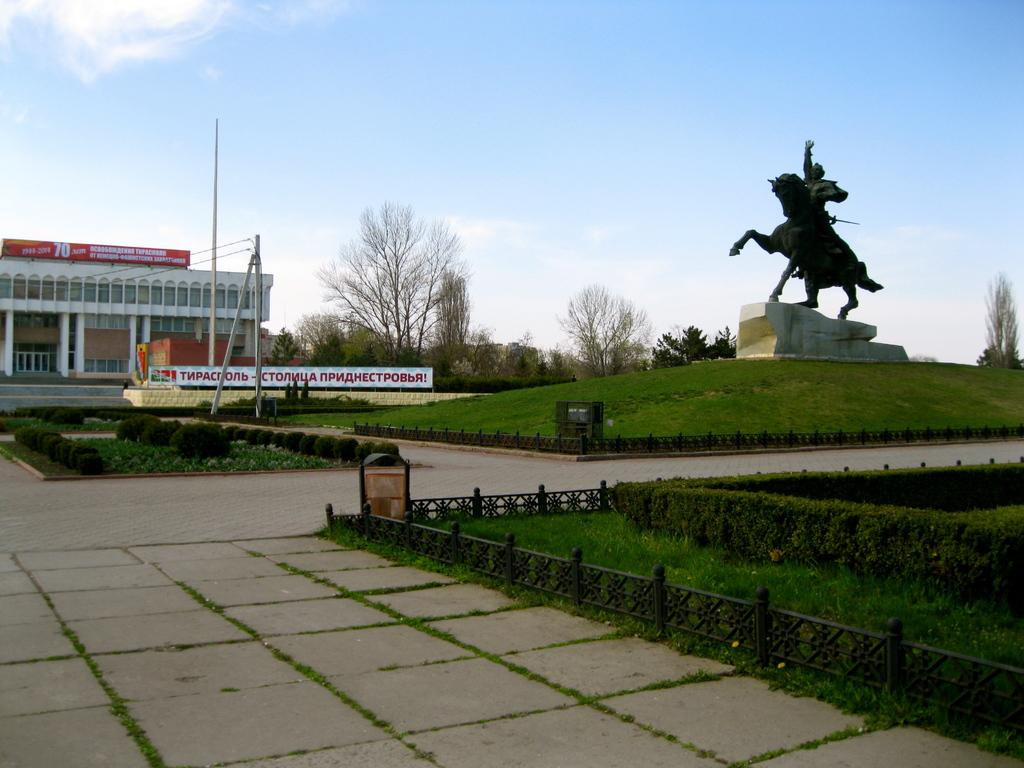What structure is located on the left side of the image? There is a house on the left side of the image. What type of landscape surrounds the house? The house appears to be surrounded by a garden. What can be seen on the right side of the image? There is a statue of a man riding a horse on the right side of the image. What type of vegetation is in the middle of the image? There are trees in the middle of the image. What is visible at the top of the image? The sky is visible at the top of the image. How many fingers can be seen on the statue of the man riding a horse? There are no fingers visible on the statue of the man riding a horse in the image. What type of line is used to measure the height of the trees in the middle of the image? There is no line or measurement tool present in the image, and the trees' heights are not being measured. 